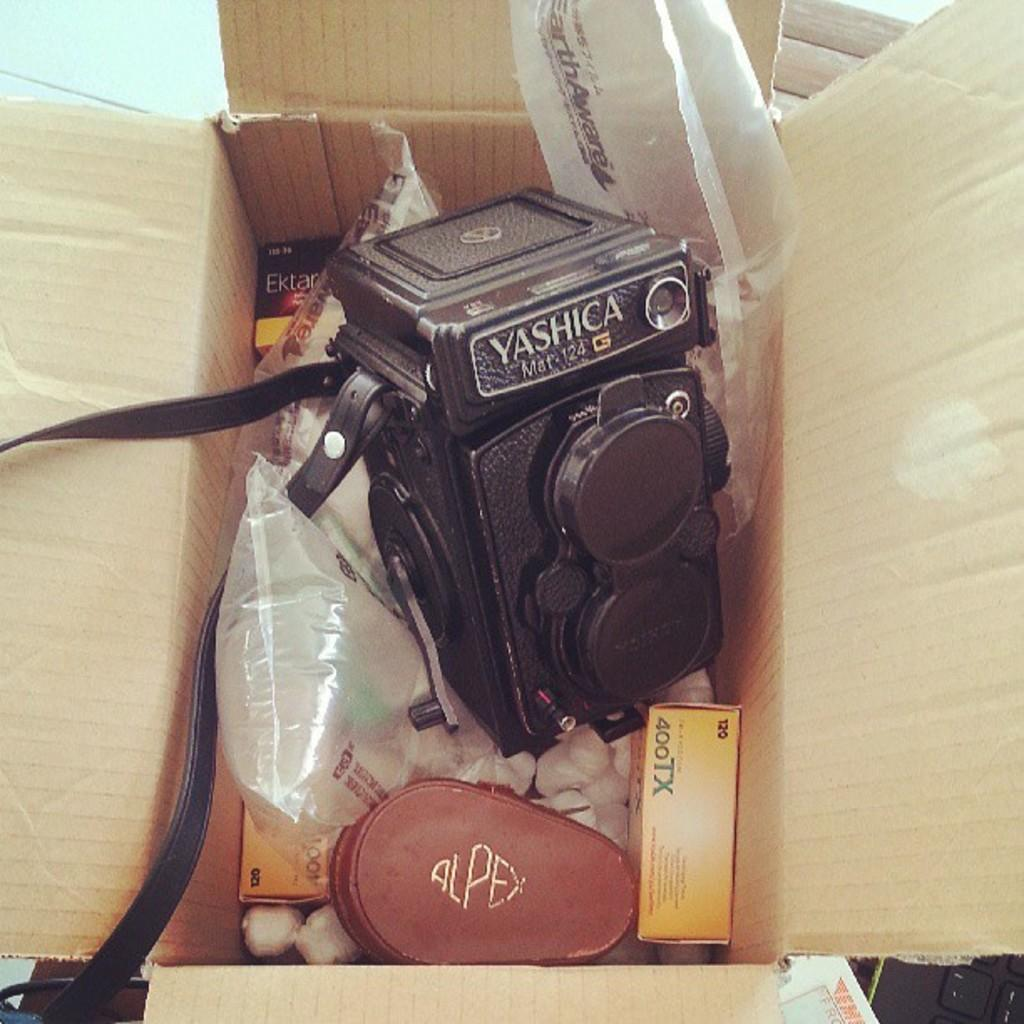What is the main object in the image? There is a camera in the image. What else can be seen in the image besides the camera? There are boxes and plastic covers in the image. Where are the camera, boxes, and plastic covers located? They are all in a carton box. Can you see any fish in the image? No, there are no fish present in the image. Does the camera in the image show any signs of regret? The image does not depict emotions or sentiments, so it cannot be determined if the camera shows any signs of regret. 